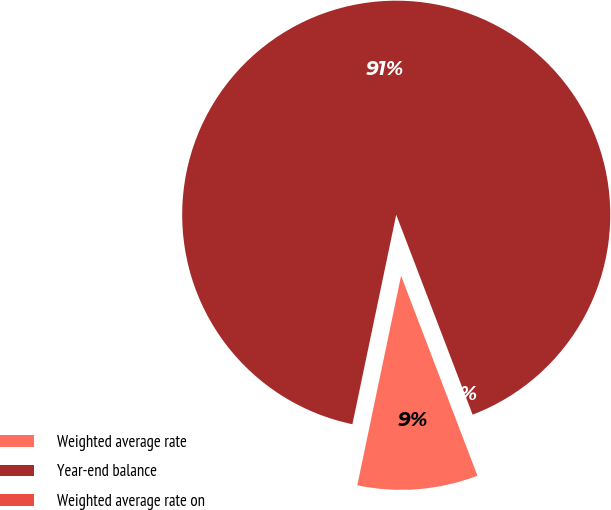Convert chart to OTSL. <chart><loc_0><loc_0><loc_500><loc_500><pie_chart><fcel>Weighted average rate<fcel>Year-end balance<fcel>Weighted average rate on<nl><fcel>9.09%<fcel>90.91%<fcel>0.0%<nl></chart> 